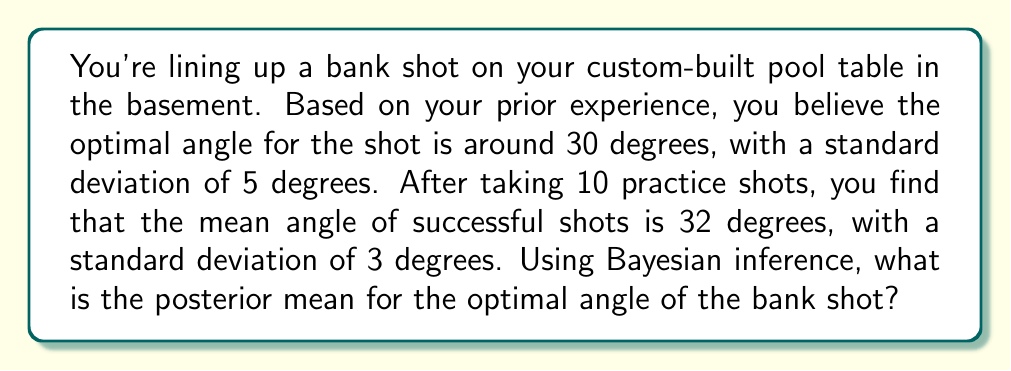Show me your answer to this math problem. Let's approach this problem using Bayesian inference:

1) Define our variables:
   $\mu$ = true optimal angle
   $\mu_0$ = prior mean = 30°
   $\sigma_0$ = prior standard deviation = 5°
   $\bar{x}$ = sample mean = 32°
   $\sigma$ = sample standard deviation = 3°
   $n$ = number of practice shots = 10

2) In Bayesian inference, we combine our prior belief with new evidence to get a posterior belief. The formula for the posterior mean in this case is:

   $$\mu_{posterior} = \frac{\frac{\mu_0}{\sigma_0^2} + \frac{n\bar{x}}{\sigma^2}}{\frac{1}{\sigma_0^2} + \frac{n}{\sigma^2}}$$

3) Let's substitute our values:

   $$\mu_{posterior} = \frac{\frac{30}{5^2} + \frac{10 \cdot 32}{3^2}}{\frac{1}{5^2} + \frac{10}{3^2}}$$

4) Simplify:

   $$\mu_{posterior} = \frac{\frac{30}{25} + \frac{320}{9}}{\frac{1}{25} + \frac{10}{9}}$$

5) Calculate the numerator and denominator separately:

   Numerator: $\frac{30}{25} + \frac{320}{9} = 1.2 + 35.56 = 36.76$
   Denominator: $\frac{1}{25} + \frac{10}{9} = 0.04 + 1.11 = 1.15$

6) Divide:

   $$\mu_{posterior} = \frac{36.76}{1.15} = 31.97$$

Therefore, the posterior mean for the optimal angle of the bank shot is approximately 31.97 degrees.
Answer: 31.97 degrees 